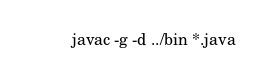<code> <loc_0><loc_0><loc_500><loc_500><_Bash_>javac -g -d ../bin *.java
</code> 